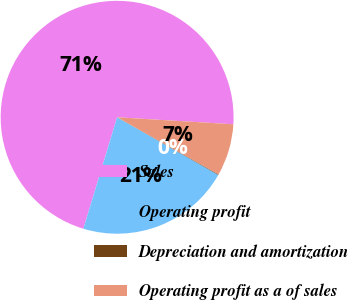Convert chart. <chart><loc_0><loc_0><loc_500><loc_500><pie_chart><fcel>Sales<fcel>Operating profit<fcel>Depreciation and amortization<fcel>Operating profit as a of sales<nl><fcel>71.27%<fcel>21.44%<fcel>0.08%<fcel>7.2%<nl></chart> 